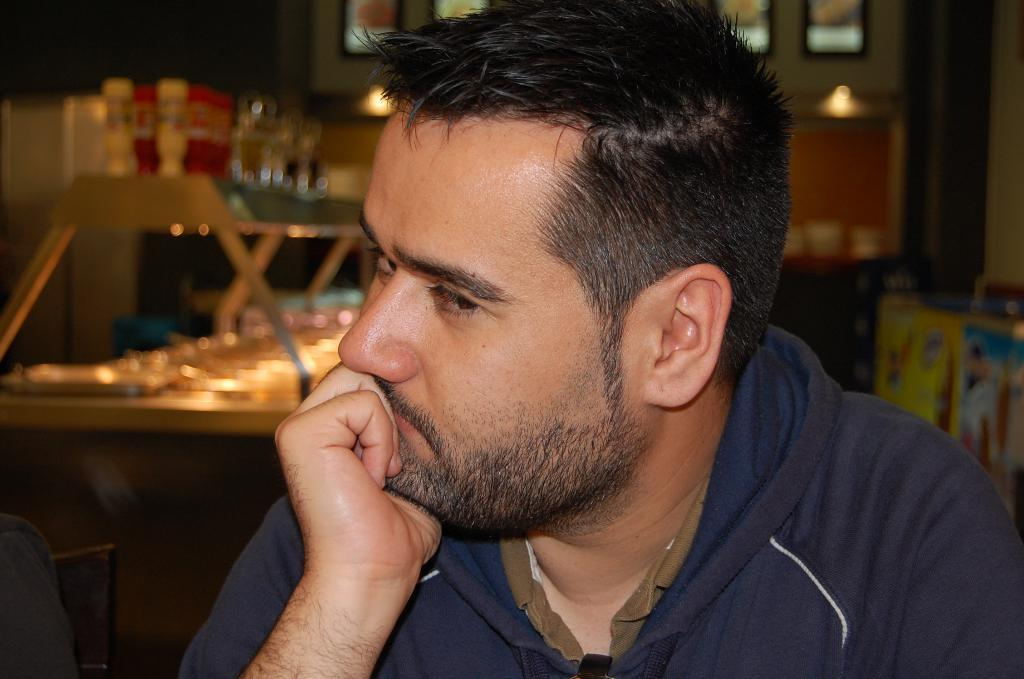What is the main subject of the image? There is a man in the image. What is the man wearing in the image? The man is wearing a hoodie. Can you describe the quality of the image in the background? The image is blurry in the background. What type of faucet can be seen in the image? There is no faucet present in the image. What color is the linen on the man's bed in the image? There is no bed or linen present in the image. 